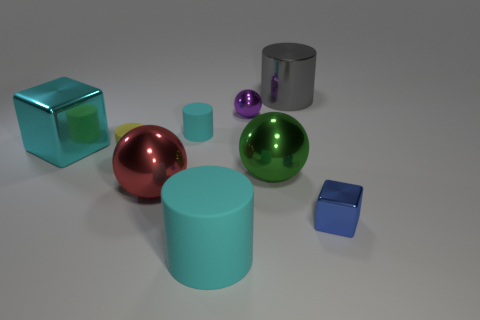There is a large metallic thing behind the large cyan cube; is it the same shape as the large red metallic thing?
Your response must be concise. No. Is the number of gray shiny objects in front of the large gray object greater than the number of matte objects on the right side of the small block?
Provide a succinct answer. No. What number of small purple objects have the same material as the red sphere?
Your answer should be very brief. 1. Do the green object and the yellow cylinder have the same size?
Your answer should be very brief. No. The big rubber cylinder has what color?
Make the answer very short. Cyan. How many objects are either big gray metal cylinders or tiny things?
Your response must be concise. 5. Are there any large cyan things of the same shape as the blue metallic thing?
Offer a very short reply. Yes. Do the matte cylinder that is behind the big cyan metallic thing and the large shiny block have the same color?
Give a very brief answer. Yes. The cyan rubber object that is on the right side of the tiny cyan thing to the right of the big red metal sphere is what shape?
Your answer should be very brief. Cylinder. Is there a yellow cylinder that has the same size as the blue metallic thing?
Provide a short and direct response. Yes. 